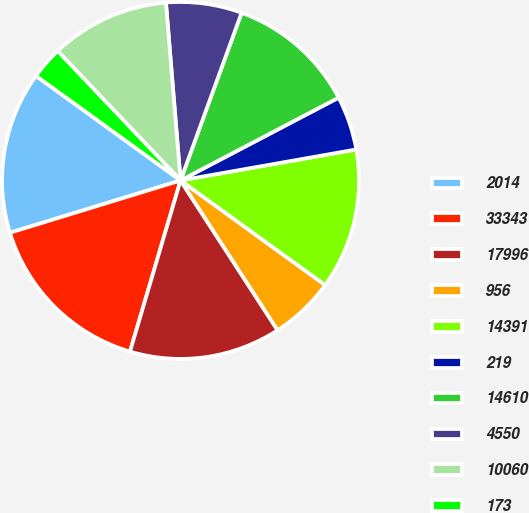Convert chart to OTSL. <chart><loc_0><loc_0><loc_500><loc_500><pie_chart><fcel>2014<fcel>33343<fcel>17996<fcel>956<fcel>14391<fcel>219<fcel>14610<fcel>4550<fcel>10060<fcel>173<nl><fcel>14.7%<fcel>15.69%<fcel>13.72%<fcel>5.88%<fcel>12.74%<fcel>4.9%<fcel>11.76%<fcel>6.86%<fcel>10.78%<fcel>2.94%<nl></chart> 